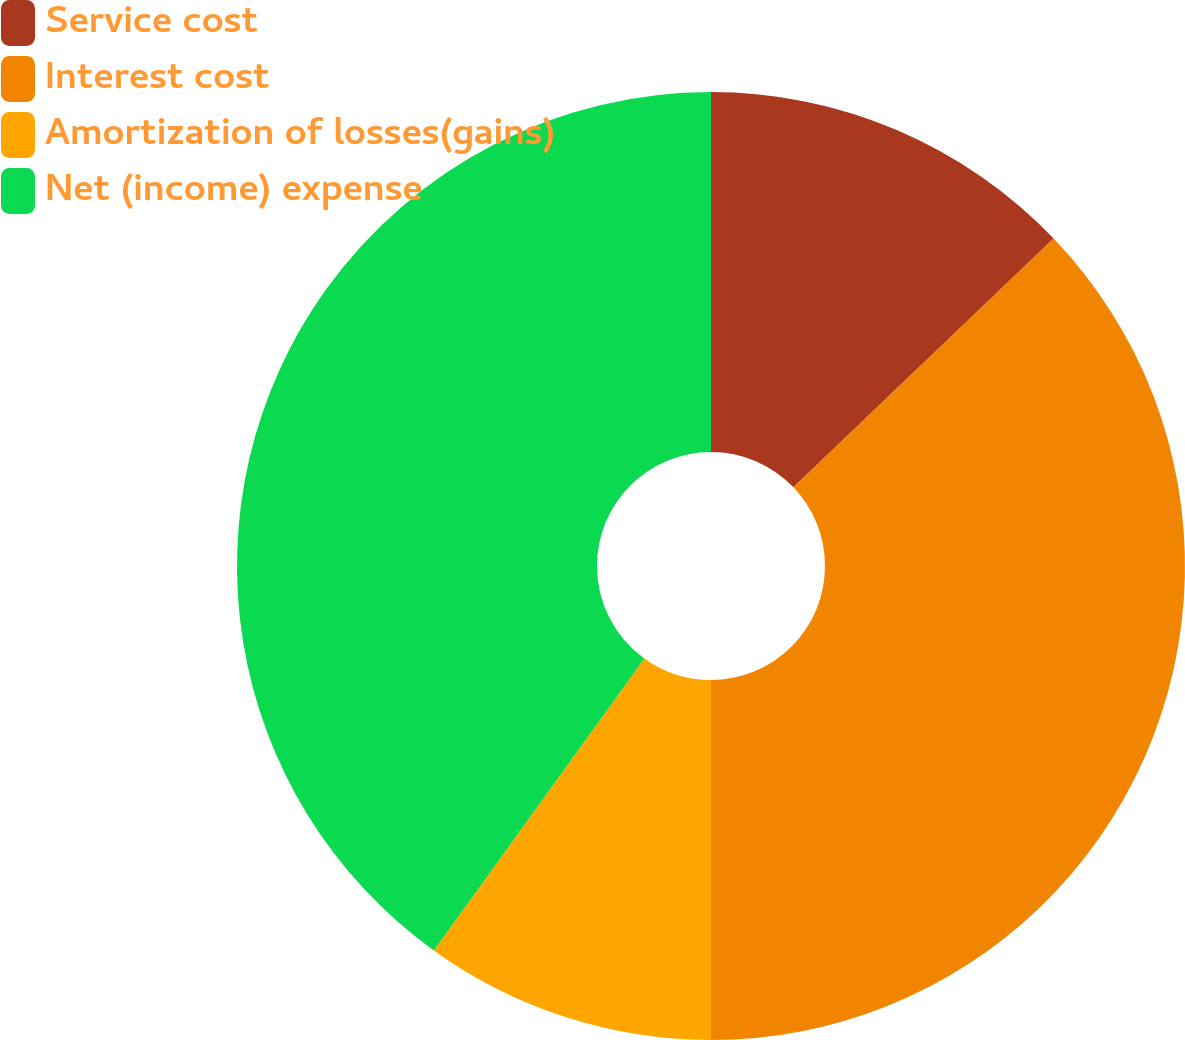Convert chart to OTSL. <chart><loc_0><loc_0><loc_500><loc_500><pie_chart><fcel>Service cost<fcel>Interest cost<fcel>Amortization of losses(gains)<fcel>Net (income) expense<nl><fcel>12.86%<fcel>37.14%<fcel>9.94%<fcel>40.06%<nl></chart> 